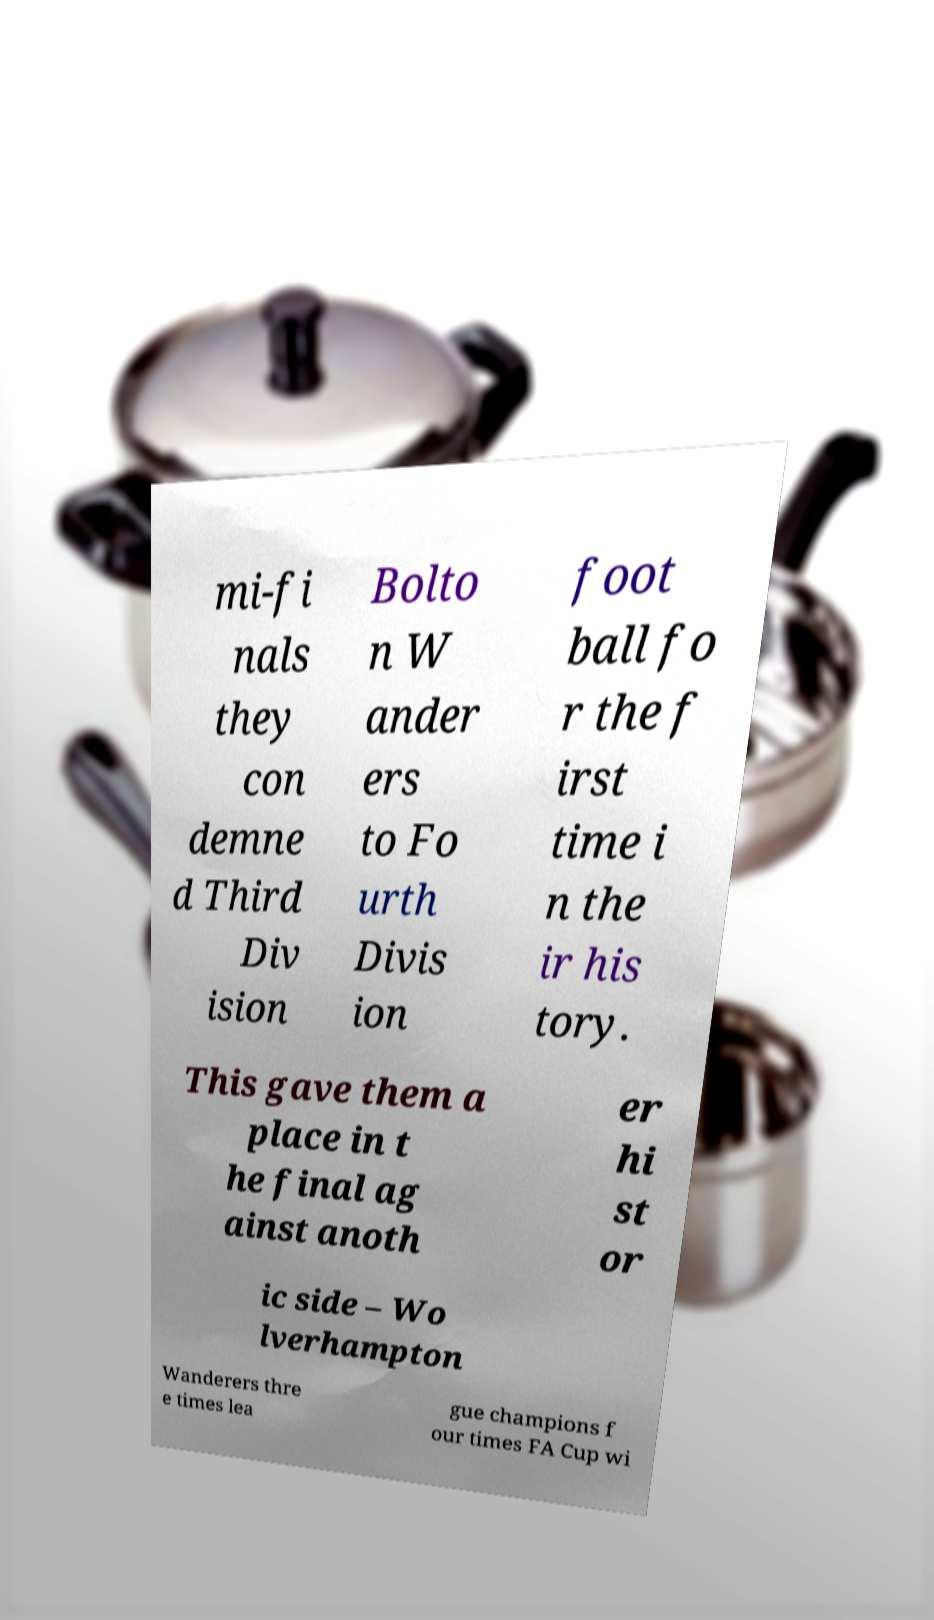What messages or text are displayed in this image? I need them in a readable, typed format. mi-fi nals they con demne d Third Div ision Bolto n W ander ers to Fo urth Divis ion foot ball fo r the f irst time i n the ir his tory. This gave them a place in t he final ag ainst anoth er hi st or ic side – Wo lverhampton Wanderers thre e times lea gue champions f our times FA Cup wi 